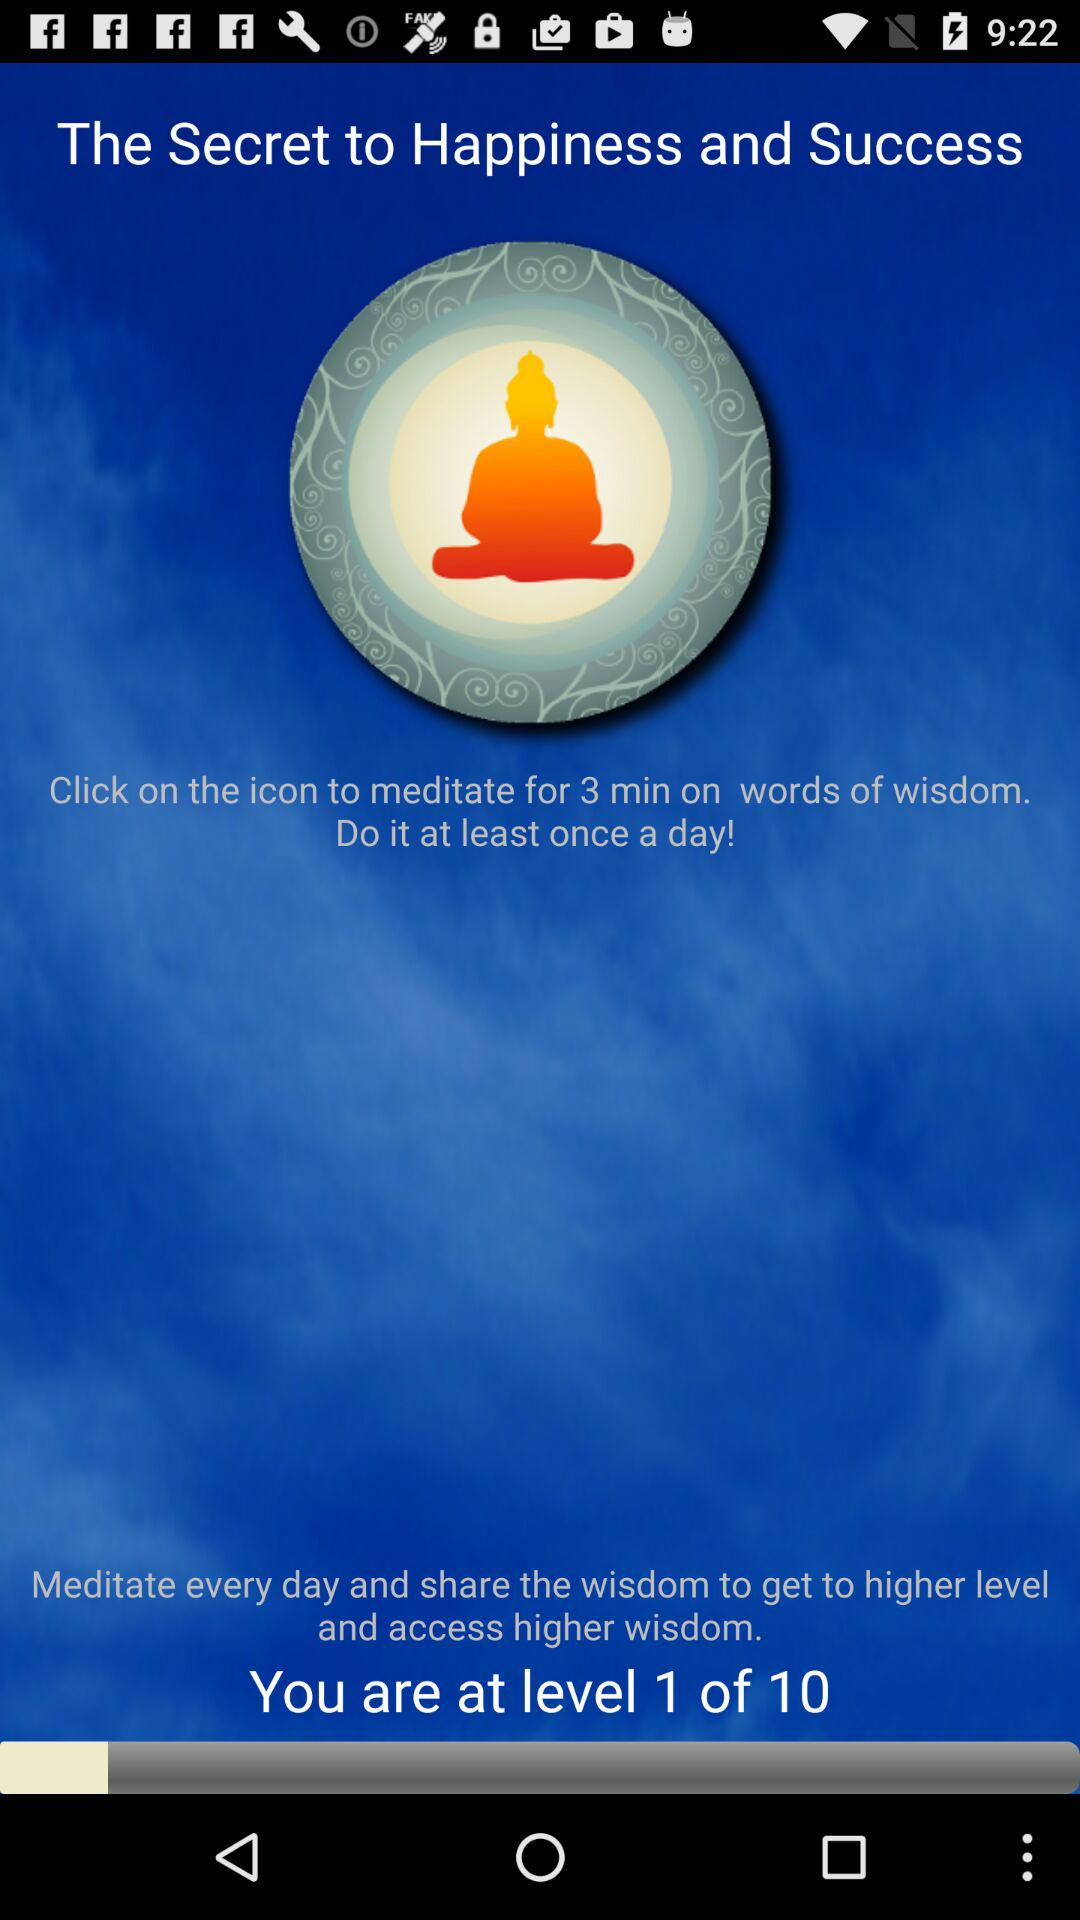How many more levels are there than the current level?
Answer the question using a single word or phrase. 9 